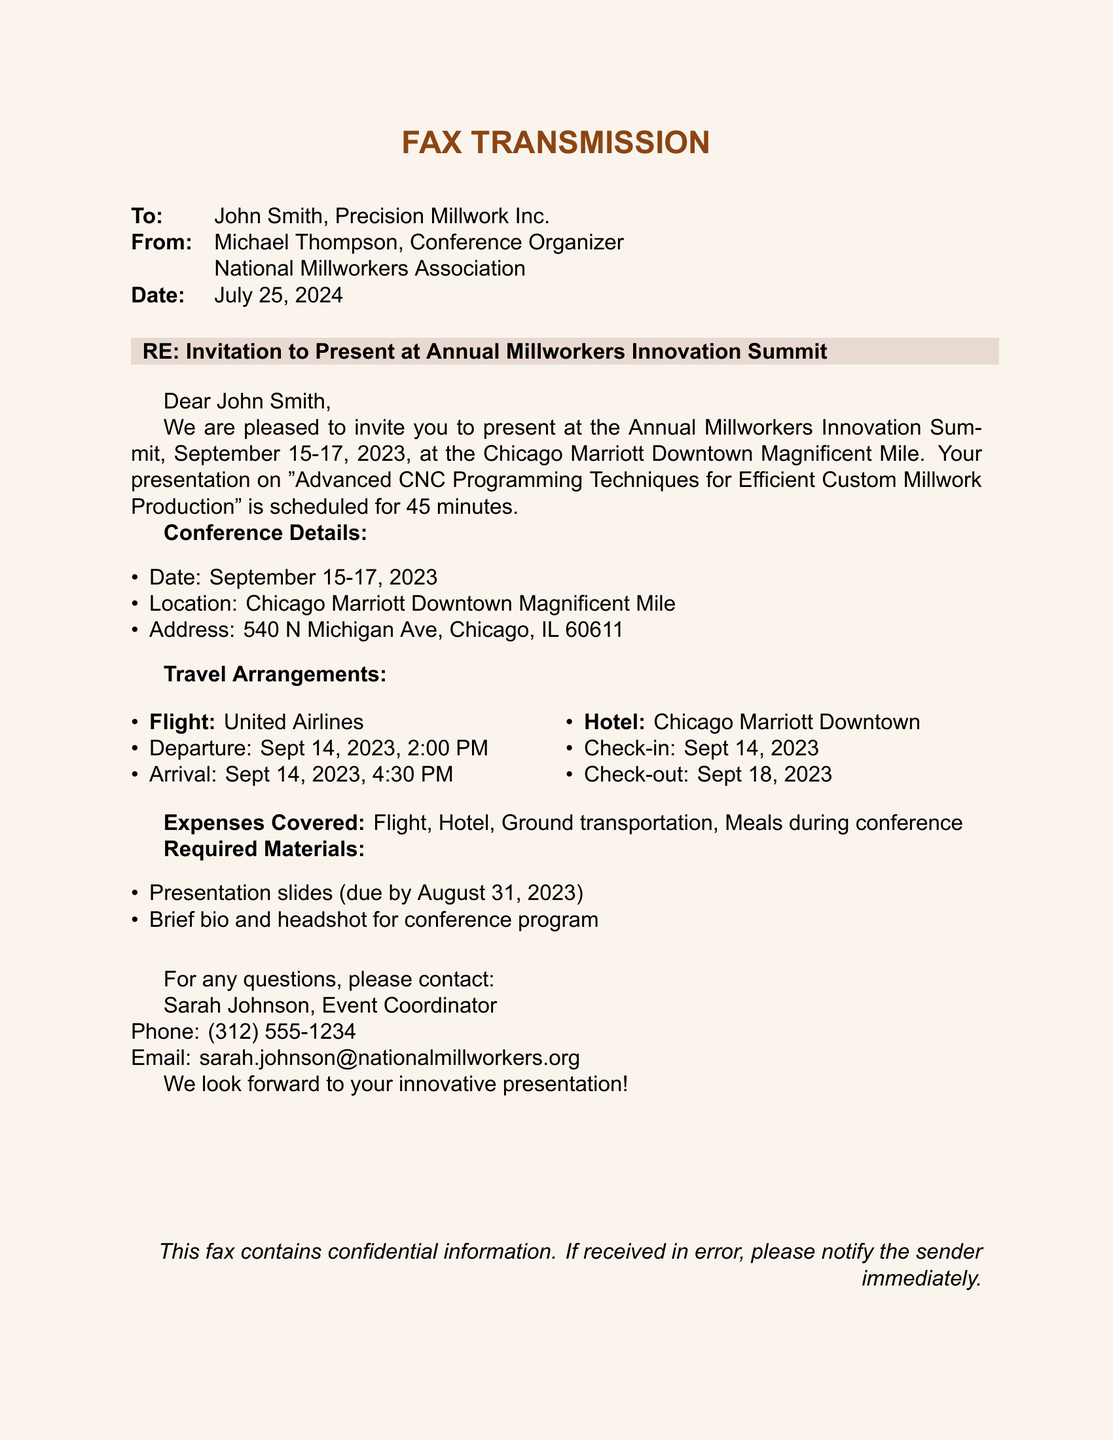What is the date of the conference? The date of the conference is specified as September 15-17, 2023.
Answer: September 15-17, 2023 Who is the sender of the fax? The sender of the fax is Michael Thompson, the Conference Organizer at the National Millworkers Association.
Answer: Michael Thompson What is the title of the presentation? The title of the presentation mentioned is "Advanced CNC Programming Techniques for Efficient Custom Millwork Production."
Answer: Advanced CNC Programming Techniques for Efficient Custom Millwork Production What airline will be used for the flight? The fax specifies that United Airlines will be used for the flight arrangements.
Answer: United Airlines When are the presentation materials due? The due date for the presentation materials is stated as August 31, 2023.
Answer: August 31, 2023 What is included in the expenses covered? The fax outlines the covered expenses as flight, hotel, ground transportation, and meals during the conference.
Answer: Flight, Hotel, Ground transportation, Meals during conference What is the check-in date for the hotel? The check-in date for the hotel is stated to be September 14, 2023.
Answer: September 14, 2023 Who should be contacted for questions? The fax provides contact information for Sarah Johnson as the person to reach out to for any questions.
Answer: Sarah Johnson 